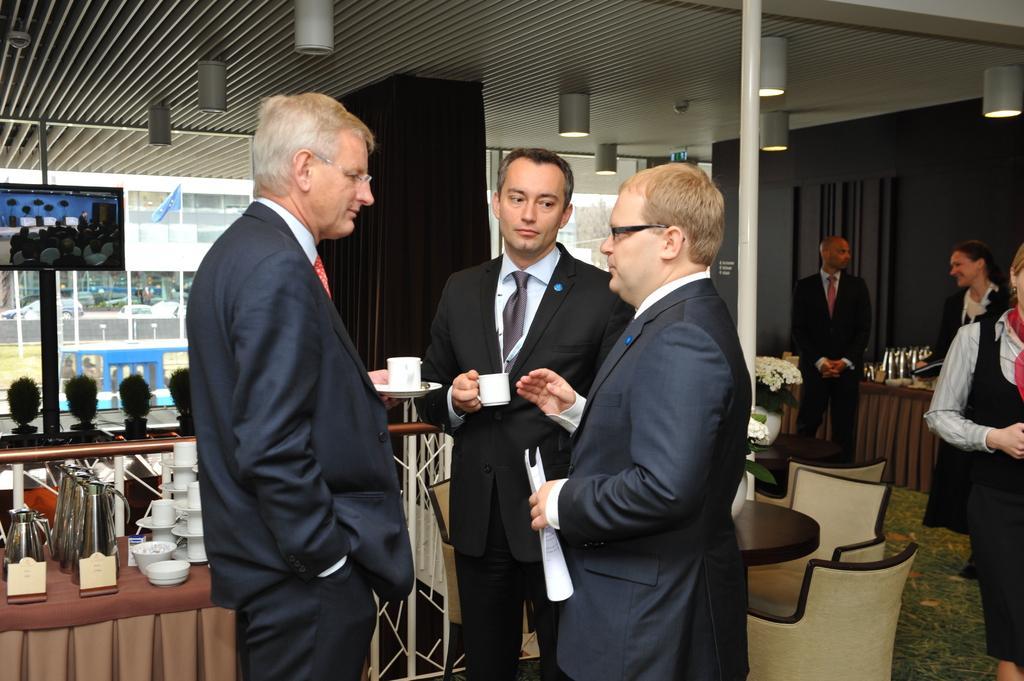Please provide a concise description of this image. In this image we can see some people standing on the floor. In that two men are holding the cups. One person is holding the papers. On the left side we can see a table containing a jar, cups, saucer and some bowls. On the backside we can see some plants, a television, the flag, pole, chairs, a flower pot and a roof with some ceiling lights. 